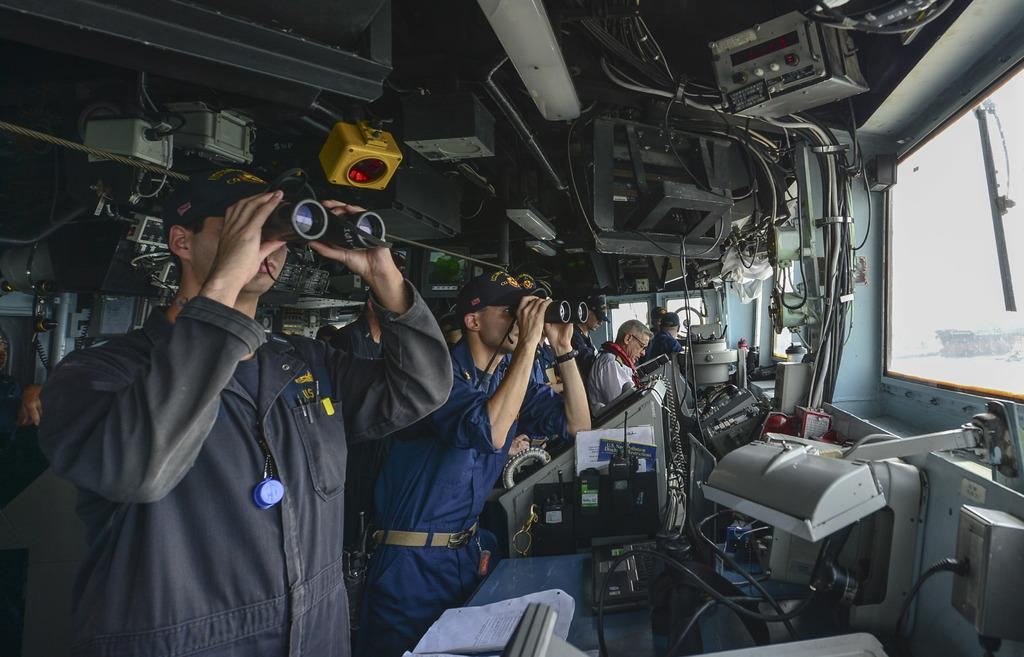What are the people holding in the image? The people in the image are holding binoculars. What are the other people in the image doing? There are other people standing in the image. What type of equipment can be seen in the image? There is equipment visible in the image. What else can be seen in the image besides the people and equipment? There are wires and papers visible in the image. What is the purpose of the glass window in the image? The glass window is present in the image, but its purpose is not explicitly stated. Can you see any mittens being used by the giants in the image? There are no giants or mittens present in the image. What type of bait is being used by the people in the image? There is no bait present in the image; the people are holding binoculars and standing. 